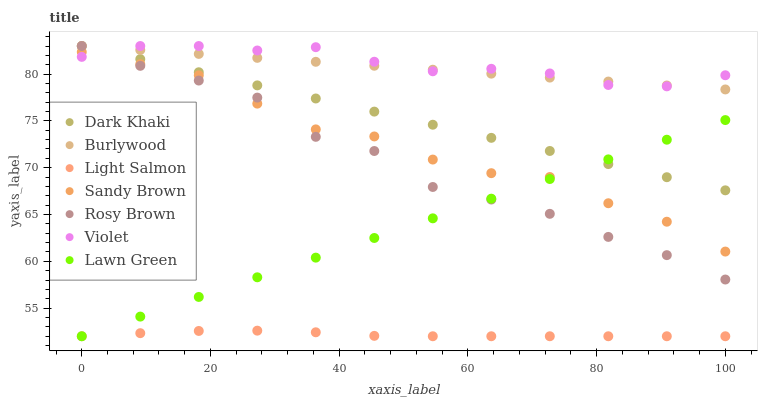Does Light Salmon have the minimum area under the curve?
Answer yes or no. Yes. Does Violet have the maximum area under the curve?
Answer yes or no. Yes. Does Burlywood have the minimum area under the curve?
Answer yes or no. No. Does Burlywood have the maximum area under the curve?
Answer yes or no. No. Is Lawn Green the smoothest?
Answer yes or no. Yes. Is Rosy Brown the roughest?
Answer yes or no. Yes. Is Light Salmon the smoothest?
Answer yes or no. No. Is Light Salmon the roughest?
Answer yes or no. No. Does Lawn Green have the lowest value?
Answer yes or no. Yes. Does Burlywood have the lowest value?
Answer yes or no. No. Does Violet have the highest value?
Answer yes or no. Yes. Does Light Salmon have the highest value?
Answer yes or no. No. Is Light Salmon less than Dark Khaki?
Answer yes or no. Yes. Is Burlywood greater than Lawn Green?
Answer yes or no. Yes. Does Dark Khaki intersect Violet?
Answer yes or no. Yes. Is Dark Khaki less than Violet?
Answer yes or no. No. Is Dark Khaki greater than Violet?
Answer yes or no. No. Does Light Salmon intersect Dark Khaki?
Answer yes or no. No. 